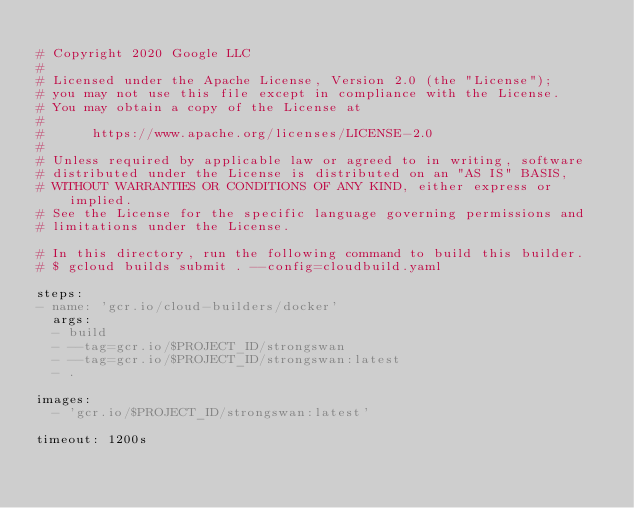<code> <loc_0><loc_0><loc_500><loc_500><_YAML_>
# Copyright 2020 Google LLC
#
# Licensed under the Apache License, Version 2.0 (the "License");
# you may not use this file except in compliance with the License.
# You may obtain a copy of the License at
#
#      https://www.apache.org/licenses/LICENSE-2.0
#
# Unless required by applicable law or agreed to in writing, software
# distributed under the License is distributed on an "AS IS" BASIS,
# WITHOUT WARRANTIES OR CONDITIONS OF ANY KIND, either express or implied.
# See the License for the specific language governing permissions and
# limitations under the License.

# In this directory, run the following command to build this builder.
# $ gcloud builds submit . --config=cloudbuild.yaml

steps:
- name: 'gcr.io/cloud-builders/docker'
  args: 
  - build 
  - --tag=gcr.io/$PROJECT_ID/strongswan
  - --tag=gcr.io/$PROJECT_ID/strongswan:latest
  - .
    
images:
  - 'gcr.io/$PROJECT_ID/strongswan:latest'
    
timeout: 1200s
</code> 